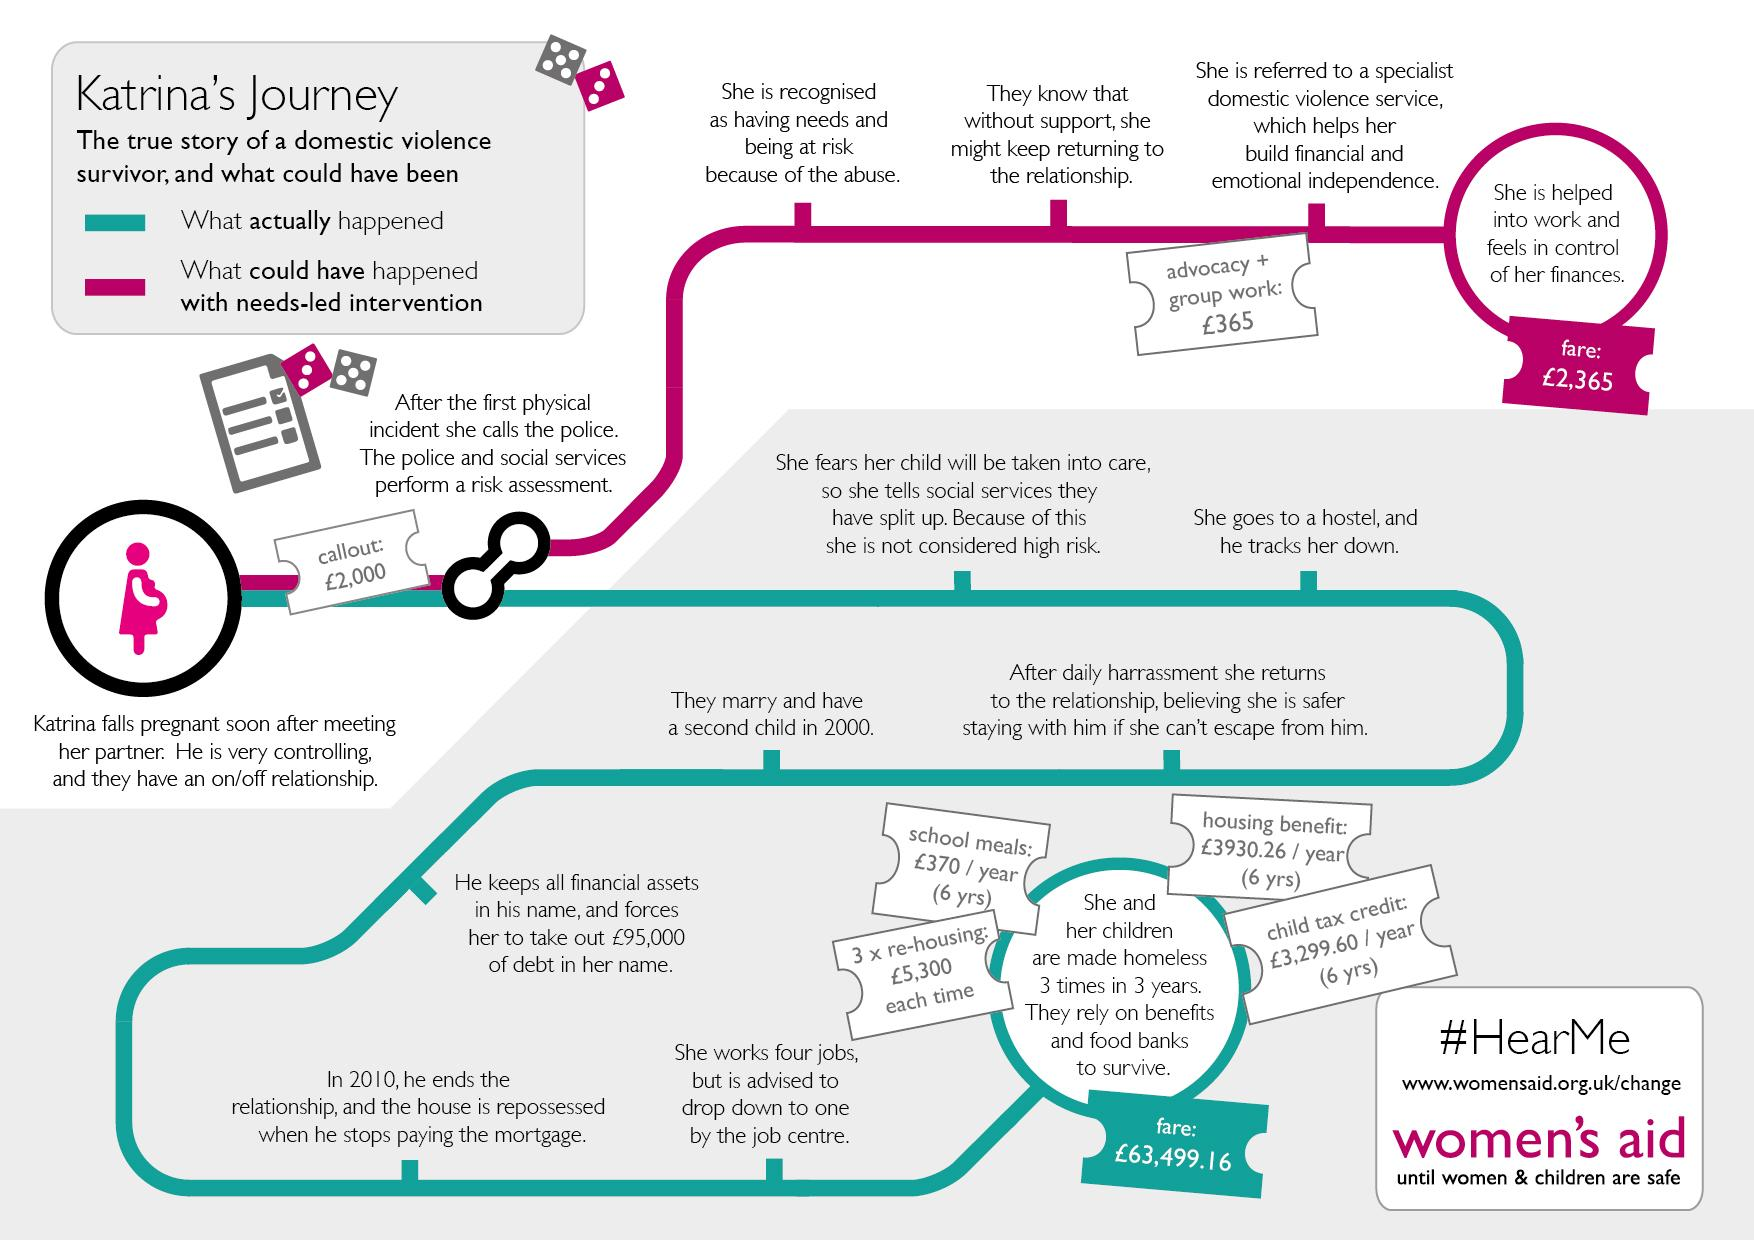Identify some key points in this picture. The total cost of school meals for 6 years was 2,220 pounds. The person who tracks down the individual when they go to a hostel is their partner. The first step performed when police and social services conduct a risk assessment is to recognize the individual as having needs and being at risk due to abuse. The actual expense incurred was higher by 61134.16 pounds than the expense that could have been incurred. The cost of re-housing three times is 15900 pounds. 